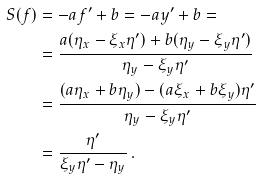<formula> <loc_0><loc_0><loc_500><loc_500>S ( f ) & = - a f ^ { \prime } + b = - a y ^ { \prime } + b = \\ & = \frac { a ( \eta _ { x } - \xi _ { x } \eta ^ { \prime } ) + b ( \eta _ { y } - \xi _ { y } \eta ^ { \prime } ) } { \eta _ { y } - \xi _ { y } \eta ^ { \prime } } \\ & = \frac { ( a \eta _ { x } + b \eta _ { y } ) - ( a \xi _ { x } + b \xi _ { y } ) \eta ^ { \prime } } { \eta _ { y } - \xi _ { y } \eta ^ { \prime } } \\ & = \frac { \eta ^ { \prime } } { \xi _ { y } \eta ^ { \prime } - \eta _ { y } } \, .</formula> 